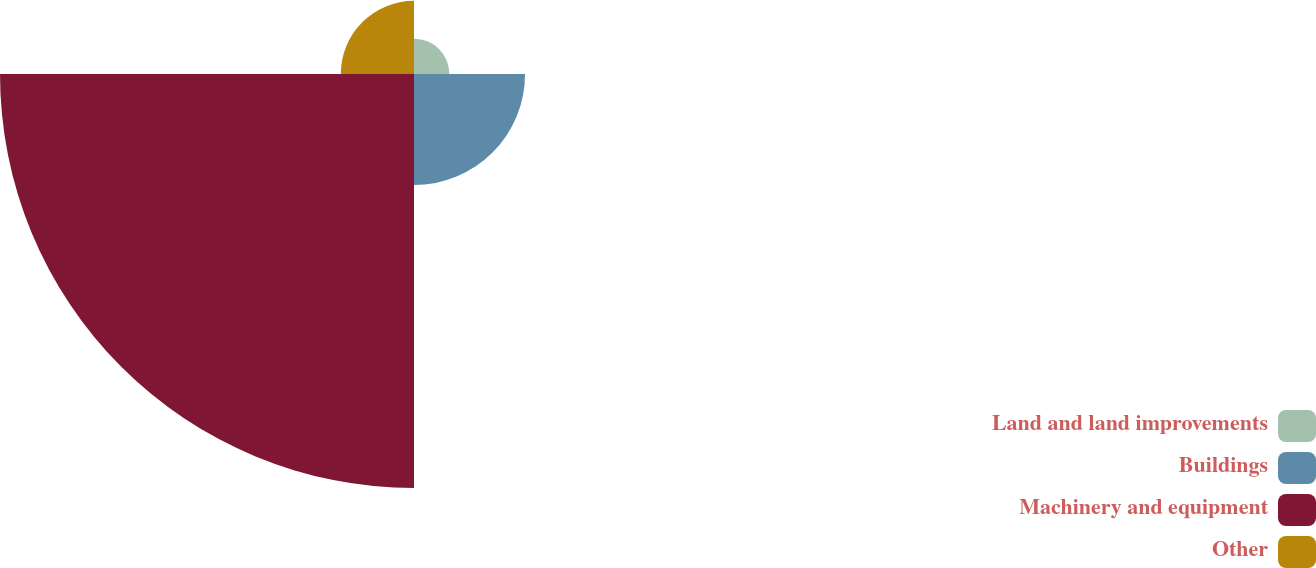Convert chart to OTSL. <chart><loc_0><loc_0><loc_500><loc_500><pie_chart><fcel>Land and land improvements<fcel>Buildings<fcel>Machinery and equipment<fcel>Other<nl><fcel>5.58%<fcel>17.53%<fcel>65.34%<fcel>11.55%<nl></chart> 